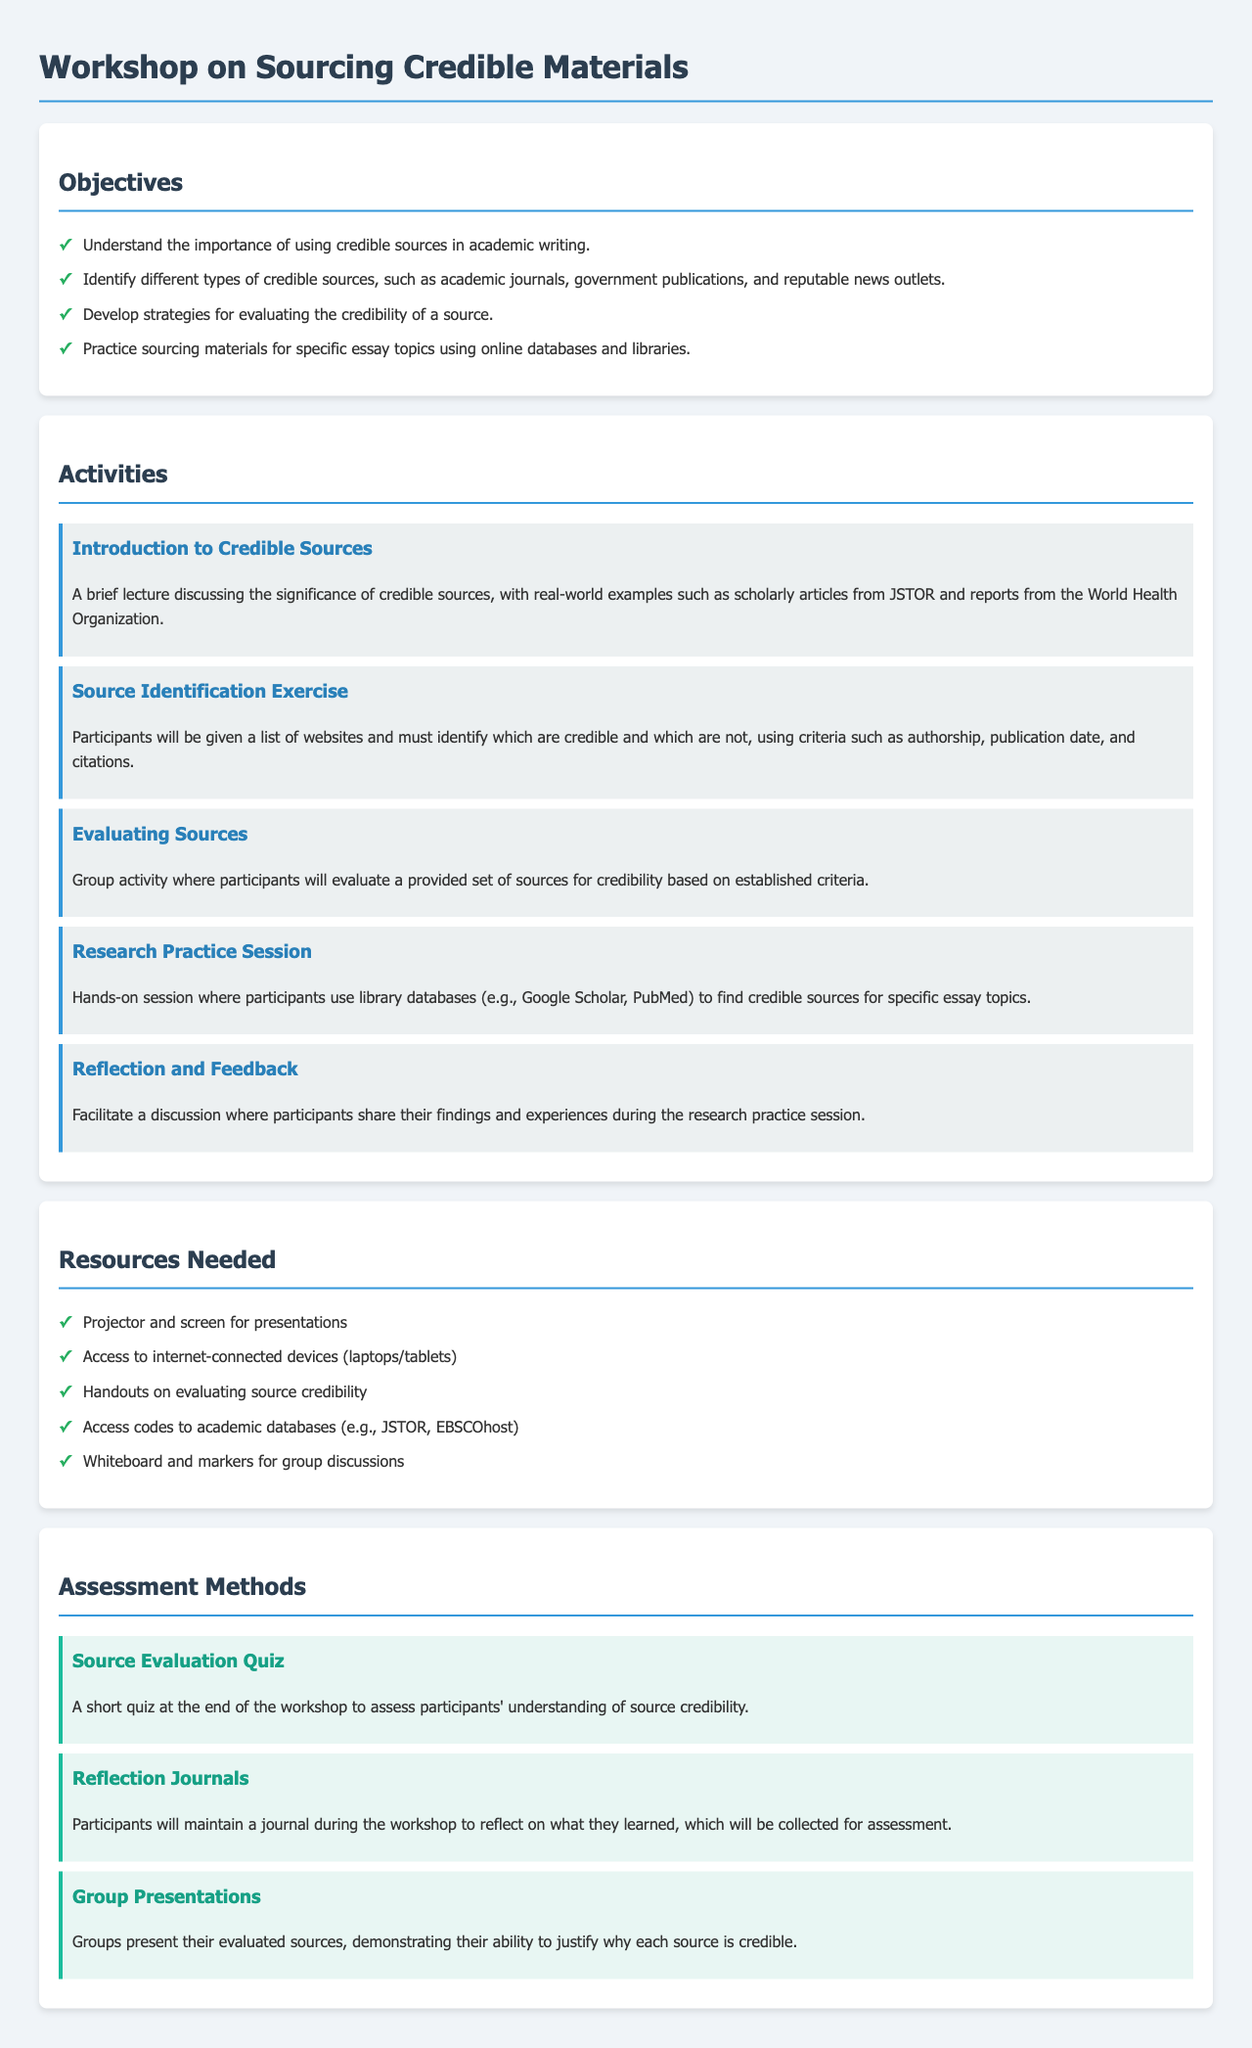what is the title of the workshop? The title of the workshop is presented at the top of the document as the heading.
Answer: Workshop on Sourcing Credible Materials how many objectives are listed in the document? The number of objectives can be found by counting the items in the objectives section.
Answer: four name one type of credible source mentioned in the objectives section. The document explicitly lists different types of credible sources in the objectives.
Answer: academic journals what is one resource needed for the workshop? Resources are listed in a dedicated section, and any item from that list would suffice as an answer.
Answer: Projector and screen for presentations how will participants demonstrate their understanding of source credibility? The assessment methods outline how participants will show what they learned, which is key to understanding evaluation.
Answer: Group Presentations what type of activity is the "Source Identification Exercise"? The activities are categorized and described in the document, indicating the nature of each.
Answer: Exercise how will participants reflect on their learning from the workshop? The methods for assessment involve activities designed for participants to reflect on their experiences.
Answer: Reflection Journals which type of quiz is mentioned in the assessment methods? The type of quiz can be found in the assessment methods section, which categorizes different forms of evaluation.
Answer: Source Evaluation Quiz what is the background color of the document's body? The background color is defined in the style section and can be identified in the document's design.
Answer: light gray 